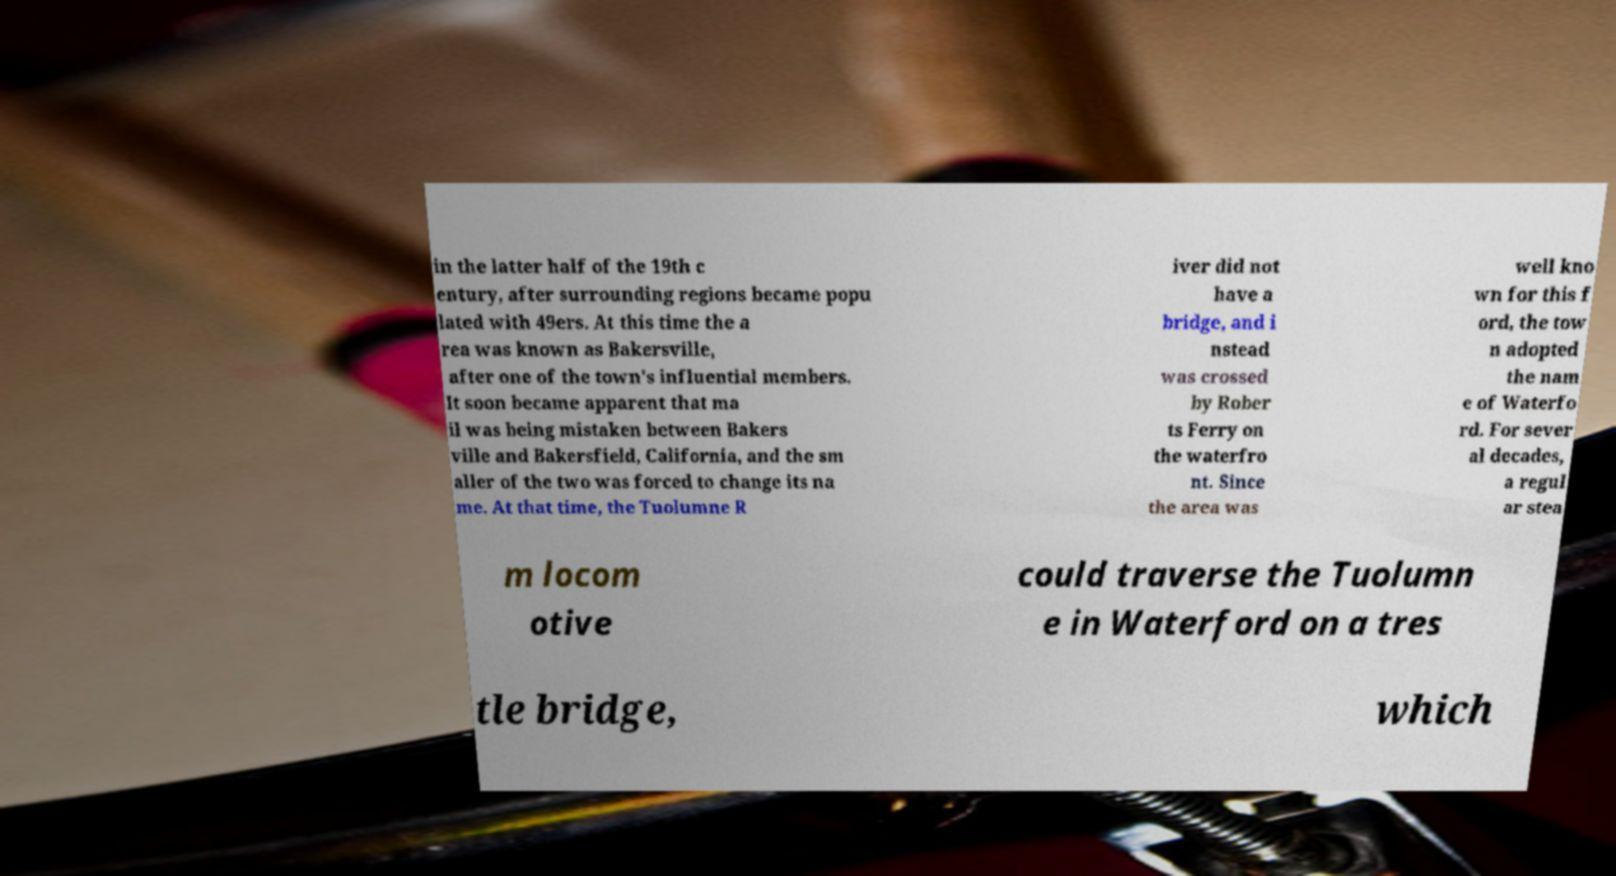Please read and relay the text visible in this image. What does it say? in the latter half of the 19th c entury, after surrounding regions became popu lated with 49ers. At this time the a rea was known as Bakersville, after one of the town's influential members. It soon became apparent that ma il was being mistaken between Bakers ville and Bakersfield, California, and the sm aller of the two was forced to change its na me. At that time, the Tuolumne R iver did not have a bridge, and i nstead was crossed by Rober ts Ferry on the waterfro nt. Since the area was well kno wn for this f ord, the tow n adopted the nam e of Waterfo rd. For sever al decades, a regul ar stea m locom otive could traverse the Tuolumn e in Waterford on a tres tle bridge, which 